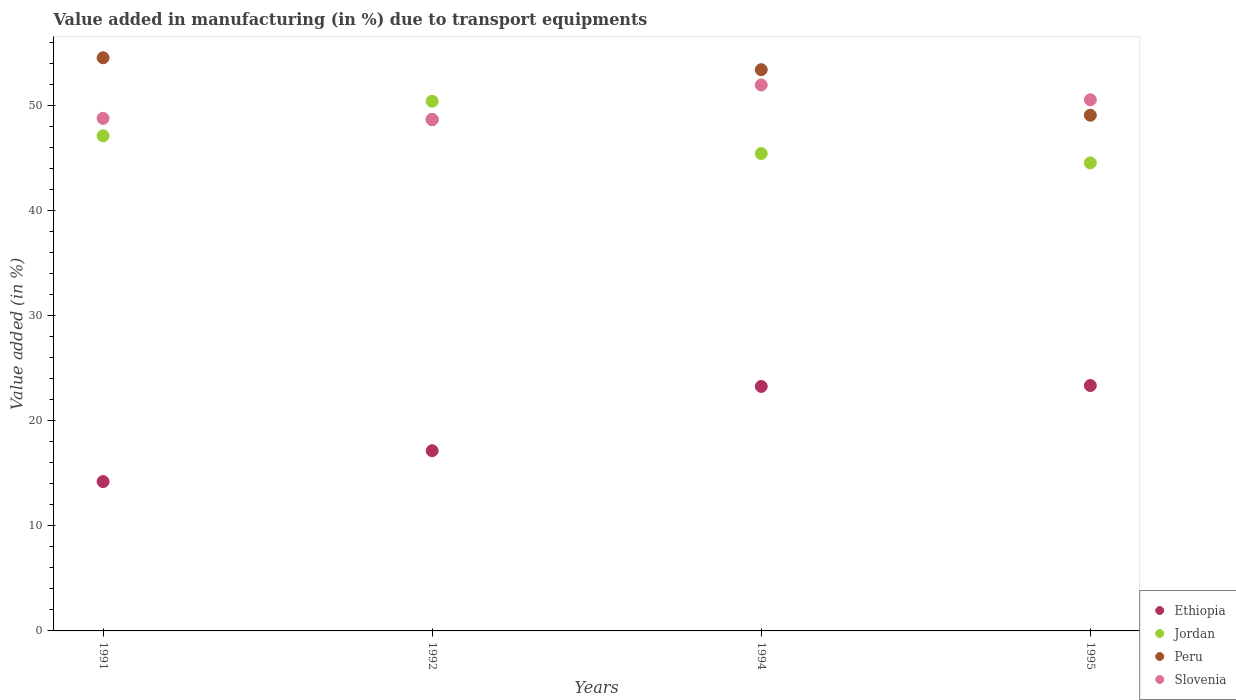How many different coloured dotlines are there?
Your answer should be compact. 4. Is the number of dotlines equal to the number of legend labels?
Provide a short and direct response. Yes. What is the percentage of value added in manufacturing due to transport equipments in Jordan in 1995?
Ensure brevity in your answer.  44.55. Across all years, what is the maximum percentage of value added in manufacturing due to transport equipments in Jordan?
Provide a succinct answer. 50.42. Across all years, what is the minimum percentage of value added in manufacturing due to transport equipments in Jordan?
Offer a very short reply. 44.55. In which year was the percentage of value added in manufacturing due to transport equipments in Ethiopia minimum?
Ensure brevity in your answer.  1991. What is the total percentage of value added in manufacturing due to transport equipments in Ethiopia in the graph?
Make the answer very short. 78. What is the difference between the percentage of value added in manufacturing due to transport equipments in Slovenia in 1994 and that in 1995?
Your response must be concise. 1.41. What is the difference between the percentage of value added in manufacturing due to transport equipments in Peru in 1991 and the percentage of value added in manufacturing due to transport equipments in Ethiopia in 1994?
Your answer should be very brief. 31.28. What is the average percentage of value added in manufacturing due to transport equipments in Jordan per year?
Your answer should be compact. 46.88. In the year 1995, what is the difference between the percentage of value added in manufacturing due to transport equipments in Slovenia and percentage of value added in manufacturing due to transport equipments in Peru?
Provide a succinct answer. 1.47. What is the ratio of the percentage of value added in manufacturing due to transport equipments in Peru in 1994 to that in 1995?
Offer a terse response. 1.09. Is the percentage of value added in manufacturing due to transport equipments in Jordan in 1992 less than that in 1995?
Offer a very short reply. No. Is the difference between the percentage of value added in manufacturing due to transport equipments in Slovenia in 1991 and 1992 greater than the difference between the percentage of value added in manufacturing due to transport equipments in Peru in 1991 and 1992?
Your answer should be compact. No. What is the difference between the highest and the second highest percentage of value added in manufacturing due to transport equipments in Ethiopia?
Make the answer very short. 0.09. What is the difference between the highest and the lowest percentage of value added in manufacturing due to transport equipments in Slovenia?
Make the answer very short. 3.29. Is the sum of the percentage of value added in manufacturing due to transport equipments in Peru in 1991 and 1994 greater than the maximum percentage of value added in manufacturing due to transport equipments in Ethiopia across all years?
Ensure brevity in your answer.  Yes. Does the percentage of value added in manufacturing due to transport equipments in Slovenia monotonically increase over the years?
Offer a very short reply. No. Is the percentage of value added in manufacturing due to transport equipments in Jordan strictly greater than the percentage of value added in manufacturing due to transport equipments in Peru over the years?
Keep it short and to the point. No. How many years are there in the graph?
Provide a short and direct response. 4. Does the graph contain any zero values?
Provide a short and direct response. No. Where does the legend appear in the graph?
Offer a terse response. Bottom right. How many legend labels are there?
Offer a terse response. 4. What is the title of the graph?
Keep it short and to the point. Value added in manufacturing (in %) due to transport equipments. Does "United Arab Emirates" appear as one of the legend labels in the graph?
Give a very brief answer. No. What is the label or title of the Y-axis?
Your answer should be compact. Value added (in %). What is the Value added (in %) of Ethiopia in 1991?
Ensure brevity in your answer.  14.22. What is the Value added (in %) of Jordan in 1991?
Provide a succinct answer. 47.12. What is the Value added (in %) in Peru in 1991?
Provide a succinct answer. 54.55. What is the Value added (in %) of Slovenia in 1991?
Your answer should be very brief. 48.79. What is the Value added (in %) of Ethiopia in 1992?
Ensure brevity in your answer.  17.15. What is the Value added (in %) of Jordan in 1992?
Offer a terse response. 50.42. What is the Value added (in %) of Peru in 1992?
Make the answer very short. 48.67. What is the Value added (in %) of Slovenia in 1992?
Your response must be concise. 48.68. What is the Value added (in %) of Ethiopia in 1994?
Offer a very short reply. 23.27. What is the Value added (in %) of Jordan in 1994?
Your answer should be compact. 45.44. What is the Value added (in %) in Peru in 1994?
Offer a very short reply. 53.42. What is the Value added (in %) of Slovenia in 1994?
Provide a short and direct response. 51.96. What is the Value added (in %) in Ethiopia in 1995?
Offer a terse response. 23.36. What is the Value added (in %) in Jordan in 1995?
Offer a terse response. 44.55. What is the Value added (in %) of Peru in 1995?
Provide a succinct answer. 49.08. What is the Value added (in %) of Slovenia in 1995?
Your answer should be very brief. 50.55. Across all years, what is the maximum Value added (in %) of Ethiopia?
Your response must be concise. 23.36. Across all years, what is the maximum Value added (in %) in Jordan?
Ensure brevity in your answer.  50.42. Across all years, what is the maximum Value added (in %) in Peru?
Offer a terse response. 54.55. Across all years, what is the maximum Value added (in %) of Slovenia?
Provide a short and direct response. 51.96. Across all years, what is the minimum Value added (in %) of Ethiopia?
Provide a succinct answer. 14.22. Across all years, what is the minimum Value added (in %) in Jordan?
Offer a very short reply. 44.55. Across all years, what is the minimum Value added (in %) of Peru?
Offer a terse response. 48.67. Across all years, what is the minimum Value added (in %) in Slovenia?
Provide a short and direct response. 48.68. What is the total Value added (in %) in Ethiopia in the graph?
Ensure brevity in your answer.  78. What is the total Value added (in %) in Jordan in the graph?
Provide a succinct answer. 187.53. What is the total Value added (in %) in Peru in the graph?
Your response must be concise. 205.73. What is the total Value added (in %) in Slovenia in the graph?
Keep it short and to the point. 199.98. What is the difference between the Value added (in %) of Ethiopia in 1991 and that in 1992?
Give a very brief answer. -2.94. What is the difference between the Value added (in %) of Jordan in 1991 and that in 1992?
Your answer should be compact. -3.29. What is the difference between the Value added (in %) of Peru in 1991 and that in 1992?
Your response must be concise. 5.88. What is the difference between the Value added (in %) in Slovenia in 1991 and that in 1992?
Your answer should be very brief. 0.11. What is the difference between the Value added (in %) in Ethiopia in 1991 and that in 1994?
Keep it short and to the point. -9.05. What is the difference between the Value added (in %) of Jordan in 1991 and that in 1994?
Your response must be concise. 1.68. What is the difference between the Value added (in %) of Peru in 1991 and that in 1994?
Make the answer very short. 1.13. What is the difference between the Value added (in %) in Slovenia in 1991 and that in 1994?
Offer a very short reply. -3.17. What is the difference between the Value added (in %) in Ethiopia in 1991 and that in 1995?
Provide a short and direct response. -9.14. What is the difference between the Value added (in %) in Jordan in 1991 and that in 1995?
Provide a short and direct response. 2.57. What is the difference between the Value added (in %) in Peru in 1991 and that in 1995?
Provide a short and direct response. 5.47. What is the difference between the Value added (in %) of Slovenia in 1991 and that in 1995?
Provide a short and direct response. -1.76. What is the difference between the Value added (in %) of Ethiopia in 1992 and that in 1994?
Your answer should be compact. -6.12. What is the difference between the Value added (in %) of Jordan in 1992 and that in 1994?
Your answer should be very brief. 4.98. What is the difference between the Value added (in %) of Peru in 1992 and that in 1994?
Your answer should be compact. -4.75. What is the difference between the Value added (in %) in Slovenia in 1992 and that in 1994?
Offer a terse response. -3.29. What is the difference between the Value added (in %) of Ethiopia in 1992 and that in 1995?
Give a very brief answer. -6.2. What is the difference between the Value added (in %) in Jordan in 1992 and that in 1995?
Provide a short and direct response. 5.87. What is the difference between the Value added (in %) of Peru in 1992 and that in 1995?
Give a very brief answer. -0.41. What is the difference between the Value added (in %) in Slovenia in 1992 and that in 1995?
Keep it short and to the point. -1.88. What is the difference between the Value added (in %) in Ethiopia in 1994 and that in 1995?
Provide a short and direct response. -0.09. What is the difference between the Value added (in %) of Jordan in 1994 and that in 1995?
Your answer should be compact. 0.89. What is the difference between the Value added (in %) of Peru in 1994 and that in 1995?
Make the answer very short. 4.34. What is the difference between the Value added (in %) of Slovenia in 1994 and that in 1995?
Provide a succinct answer. 1.41. What is the difference between the Value added (in %) of Ethiopia in 1991 and the Value added (in %) of Jordan in 1992?
Keep it short and to the point. -36.2. What is the difference between the Value added (in %) in Ethiopia in 1991 and the Value added (in %) in Peru in 1992?
Give a very brief answer. -34.46. What is the difference between the Value added (in %) in Ethiopia in 1991 and the Value added (in %) in Slovenia in 1992?
Your response must be concise. -34.46. What is the difference between the Value added (in %) of Jordan in 1991 and the Value added (in %) of Peru in 1992?
Make the answer very short. -1.55. What is the difference between the Value added (in %) in Jordan in 1991 and the Value added (in %) in Slovenia in 1992?
Offer a terse response. -1.55. What is the difference between the Value added (in %) in Peru in 1991 and the Value added (in %) in Slovenia in 1992?
Your answer should be compact. 5.88. What is the difference between the Value added (in %) in Ethiopia in 1991 and the Value added (in %) in Jordan in 1994?
Offer a terse response. -31.23. What is the difference between the Value added (in %) of Ethiopia in 1991 and the Value added (in %) of Peru in 1994?
Your answer should be very brief. -39.21. What is the difference between the Value added (in %) in Ethiopia in 1991 and the Value added (in %) in Slovenia in 1994?
Your answer should be very brief. -37.74. What is the difference between the Value added (in %) of Jordan in 1991 and the Value added (in %) of Peru in 1994?
Give a very brief answer. -6.3. What is the difference between the Value added (in %) in Jordan in 1991 and the Value added (in %) in Slovenia in 1994?
Offer a very short reply. -4.84. What is the difference between the Value added (in %) of Peru in 1991 and the Value added (in %) of Slovenia in 1994?
Make the answer very short. 2.59. What is the difference between the Value added (in %) in Ethiopia in 1991 and the Value added (in %) in Jordan in 1995?
Ensure brevity in your answer.  -30.33. What is the difference between the Value added (in %) in Ethiopia in 1991 and the Value added (in %) in Peru in 1995?
Your answer should be compact. -34.87. What is the difference between the Value added (in %) of Ethiopia in 1991 and the Value added (in %) of Slovenia in 1995?
Offer a very short reply. -36.34. What is the difference between the Value added (in %) of Jordan in 1991 and the Value added (in %) of Peru in 1995?
Your answer should be compact. -1.96. What is the difference between the Value added (in %) in Jordan in 1991 and the Value added (in %) in Slovenia in 1995?
Ensure brevity in your answer.  -3.43. What is the difference between the Value added (in %) in Peru in 1991 and the Value added (in %) in Slovenia in 1995?
Keep it short and to the point. 4. What is the difference between the Value added (in %) in Ethiopia in 1992 and the Value added (in %) in Jordan in 1994?
Offer a very short reply. -28.29. What is the difference between the Value added (in %) in Ethiopia in 1992 and the Value added (in %) in Peru in 1994?
Give a very brief answer. -36.27. What is the difference between the Value added (in %) in Ethiopia in 1992 and the Value added (in %) in Slovenia in 1994?
Provide a succinct answer. -34.81. What is the difference between the Value added (in %) of Jordan in 1992 and the Value added (in %) of Peru in 1994?
Provide a short and direct response. -3.01. What is the difference between the Value added (in %) in Jordan in 1992 and the Value added (in %) in Slovenia in 1994?
Your response must be concise. -1.54. What is the difference between the Value added (in %) in Peru in 1992 and the Value added (in %) in Slovenia in 1994?
Your answer should be compact. -3.29. What is the difference between the Value added (in %) of Ethiopia in 1992 and the Value added (in %) of Jordan in 1995?
Give a very brief answer. -27.4. What is the difference between the Value added (in %) of Ethiopia in 1992 and the Value added (in %) of Peru in 1995?
Provide a short and direct response. -31.93. What is the difference between the Value added (in %) in Ethiopia in 1992 and the Value added (in %) in Slovenia in 1995?
Make the answer very short. -33.4. What is the difference between the Value added (in %) in Jordan in 1992 and the Value added (in %) in Peru in 1995?
Offer a very short reply. 1.33. What is the difference between the Value added (in %) of Jordan in 1992 and the Value added (in %) of Slovenia in 1995?
Provide a short and direct response. -0.14. What is the difference between the Value added (in %) in Peru in 1992 and the Value added (in %) in Slovenia in 1995?
Give a very brief answer. -1.88. What is the difference between the Value added (in %) of Ethiopia in 1994 and the Value added (in %) of Jordan in 1995?
Your response must be concise. -21.28. What is the difference between the Value added (in %) of Ethiopia in 1994 and the Value added (in %) of Peru in 1995?
Keep it short and to the point. -25.81. What is the difference between the Value added (in %) in Ethiopia in 1994 and the Value added (in %) in Slovenia in 1995?
Offer a very short reply. -27.28. What is the difference between the Value added (in %) in Jordan in 1994 and the Value added (in %) in Peru in 1995?
Keep it short and to the point. -3.64. What is the difference between the Value added (in %) of Jordan in 1994 and the Value added (in %) of Slovenia in 1995?
Keep it short and to the point. -5.11. What is the difference between the Value added (in %) in Peru in 1994 and the Value added (in %) in Slovenia in 1995?
Ensure brevity in your answer.  2.87. What is the average Value added (in %) of Ethiopia per year?
Give a very brief answer. 19.5. What is the average Value added (in %) in Jordan per year?
Provide a succinct answer. 46.88. What is the average Value added (in %) in Peru per year?
Provide a short and direct response. 51.43. What is the average Value added (in %) of Slovenia per year?
Make the answer very short. 49.99. In the year 1991, what is the difference between the Value added (in %) of Ethiopia and Value added (in %) of Jordan?
Offer a terse response. -32.91. In the year 1991, what is the difference between the Value added (in %) of Ethiopia and Value added (in %) of Peru?
Make the answer very short. -40.34. In the year 1991, what is the difference between the Value added (in %) of Ethiopia and Value added (in %) of Slovenia?
Keep it short and to the point. -34.57. In the year 1991, what is the difference between the Value added (in %) in Jordan and Value added (in %) in Peru?
Offer a terse response. -7.43. In the year 1991, what is the difference between the Value added (in %) in Jordan and Value added (in %) in Slovenia?
Your answer should be very brief. -1.67. In the year 1991, what is the difference between the Value added (in %) in Peru and Value added (in %) in Slovenia?
Ensure brevity in your answer.  5.76. In the year 1992, what is the difference between the Value added (in %) of Ethiopia and Value added (in %) of Jordan?
Keep it short and to the point. -33.26. In the year 1992, what is the difference between the Value added (in %) in Ethiopia and Value added (in %) in Peru?
Provide a succinct answer. -31.52. In the year 1992, what is the difference between the Value added (in %) of Ethiopia and Value added (in %) of Slovenia?
Your answer should be very brief. -31.52. In the year 1992, what is the difference between the Value added (in %) in Jordan and Value added (in %) in Peru?
Your answer should be compact. 1.74. In the year 1992, what is the difference between the Value added (in %) of Jordan and Value added (in %) of Slovenia?
Your answer should be compact. 1.74. In the year 1992, what is the difference between the Value added (in %) in Peru and Value added (in %) in Slovenia?
Provide a succinct answer. -0. In the year 1994, what is the difference between the Value added (in %) of Ethiopia and Value added (in %) of Jordan?
Keep it short and to the point. -22.17. In the year 1994, what is the difference between the Value added (in %) of Ethiopia and Value added (in %) of Peru?
Ensure brevity in your answer.  -30.15. In the year 1994, what is the difference between the Value added (in %) of Ethiopia and Value added (in %) of Slovenia?
Offer a terse response. -28.69. In the year 1994, what is the difference between the Value added (in %) of Jordan and Value added (in %) of Peru?
Offer a terse response. -7.98. In the year 1994, what is the difference between the Value added (in %) of Jordan and Value added (in %) of Slovenia?
Your response must be concise. -6.52. In the year 1994, what is the difference between the Value added (in %) of Peru and Value added (in %) of Slovenia?
Your answer should be compact. 1.46. In the year 1995, what is the difference between the Value added (in %) in Ethiopia and Value added (in %) in Jordan?
Your response must be concise. -21.19. In the year 1995, what is the difference between the Value added (in %) in Ethiopia and Value added (in %) in Peru?
Your response must be concise. -25.73. In the year 1995, what is the difference between the Value added (in %) of Ethiopia and Value added (in %) of Slovenia?
Provide a succinct answer. -27.2. In the year 1995, what is the difference between the Value added (in %) of Jordan and Value added (in %) of Peru?
Make the answer very short. -4.53. In the year 1995, what is the difference between the Value added (in %) in Jordan and Value added (in %) in Slovenia?
Offer a terse response. -6. In the year 1995, what is the difference between the Value added (in %) in Peru and Value added (in %) in Slovenia?
Provide a short and direct response. -1.47. What is the ratio of the Value added (in %) of Ethiopia in 1991 to that in 1992?
Make the answer very short. 0.83. What is the ratio of the Value added (in %) in Jordan in 1991 to that in 1992?
Offer a very short reply. 0.93. What is the ratio of the Value added (in %) of Peru in 1991 to that in 1992?
Your answer should be compact. 1.12. What is the ratio of the Value added (in %) in Ethiopia in 1991 to that in 1994?
Give a very brief answer. 0.61. What is the ratio of the Value added (in %) of Peru in 1991 to that in 1994?
Provide a short and direct response. 1.02. What is the ratio of the Value added (in %) of Slovenia in 1991 to that in 1994?
Your answer should be compact. 0.94. What is the ratio of the Value added (in %) of Ethiopia in 1991 to that in 1995?
Provide a short and direct response. 0.61. What is the ratio of the Value added (in %) of Jordan in 1991 to that in 1995?
Your response must be concise. 1.06. What is the ratio of the Value added (in %) of Peru in 1991 to that in 1995?
Your response must be concise. 1.11. What is the ratio of the Value added (in %) of Slovenia in 1991 to that in 1995?
Make the answer very short. 0.97. What is the ratio of the Value added (in %) of Ethiopia in 1992 to that in 1994?
Provide a short and direct response. 0.74. What is the ratio of the Value added (in %) in Jordan in 1992 to that in 1994?
Make the answer very short. 1.11. What is the ratio of the Value added (in %) in Peru in 1992 to that in 1994?
Your answer should be very brief. 0.91. What is the ratio of the Value added (in %) of Slovenia in 1992 to that in 1994?
Offer a terse response. 0.94. What is the ratio of the Value added (in %) in Ethiopia in 1992 to that in 1995?
Make the answer very short. 0.73. What is the ratio of the Value added (in %) of Jordan in 1992 to that in 1995?
Make the answer very short. 1.13. What is the ratio of the Value added (in %) in Slovenia in 1992 to that in 1995?
Make the answer very short. 0.96. What is the ratio of the Value added (in %) in Peru in 1994 to that in 1995?
Provide a short and direct response. 1.09. What is the ratio of the Value added (in %) of Slovenia in 1994 to that in 1995?
Your response must be concise. 1.03. What is the difference between the highest and the second highest Value added (in %) in Ethiopia?
Ensure brevity in your answer.  0.09. What is the difference between the highest and the second highest Value added (in %) of Jordan?
Make the answer very short. 3.29. What is the difference between the highest and the second highest Value added (in %) in Peru?
Provide a succinct answer. 1.13. What is the difference between the highest and the second highest Value added (in %) of Slovenia?
Ensure brevity in your answer.  1.41. What is the difference between the highest and the lowest Value added (in %) in Ethiopia?
Keep it short and to the point. 9.14. What is the difference between the highest and the lowest Value added (in %) of Jordan?
Keep it short and to the point. 5.87. What is the difference between the highest and the lowest Value added (in %) of Peru?
Ensure brevity in your answer.  5.88. What is the difference between the highest and the lowest Value added (in %) in Slovenia?
Your response must be concise. 3.29. 